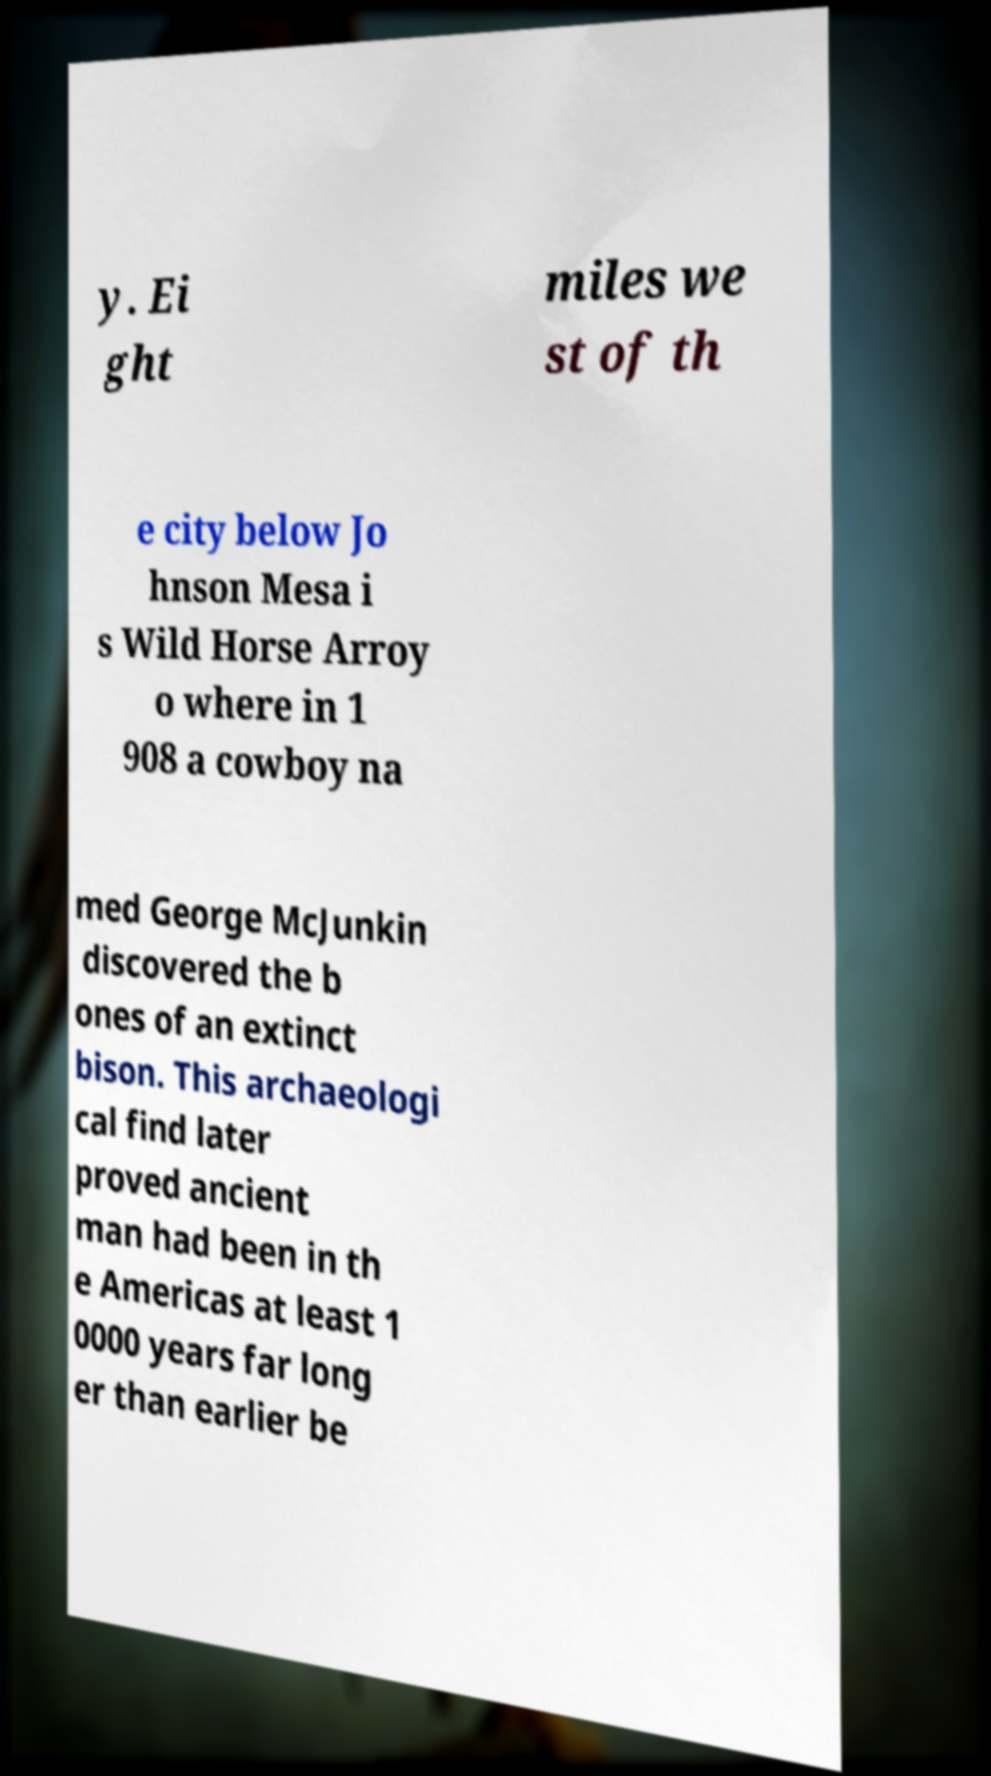Can you read and provide the text displayed in the image?This photo seems to have some interesting text. Can you extract and type it out for me? y. Ei ght miles we st of th e city below Jo hnson Mesa i s Wild Horse Arroy o where in 1 908 a cowboy na med George McJunkin discovered the b ones of an extinct bison. This archaeologi cal find later proved ancient man had been in th e Americas at least 1 0000 years far long er than earlier be 